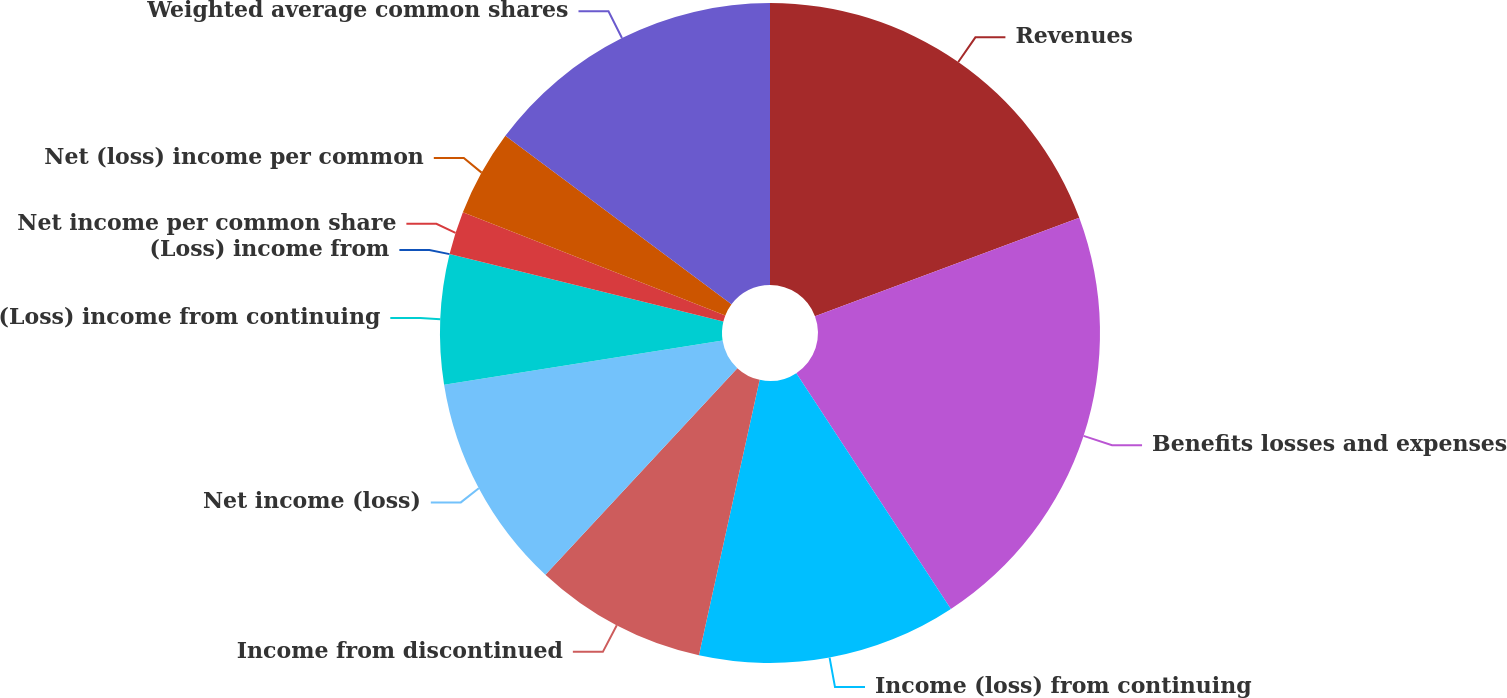Convert chart. <chart><loc_0><loc_0><loc_500><loc_500><pie_chart><fcel>Revenues<fcel>Benefits losses and expenses<fcel>Income (loss) from continuing<fcel>Income from discontinued<fcel>Net income (loss)<fcel>(Loss) income from continuing<fcel>(Loss) income from<fcel>Net income per common share<fcel>Net (loss) income per common<fcel>Weighted average common shares<nl><fcel>19.33%<fcel>21.44%<fcel>12.69%<fcel>8.46%<fcel>10.58%<fcel>6.35%<fcel>0.0%<fcel>2.12%<fcel>4.23%<fcel>14.81%<nl></chart> 